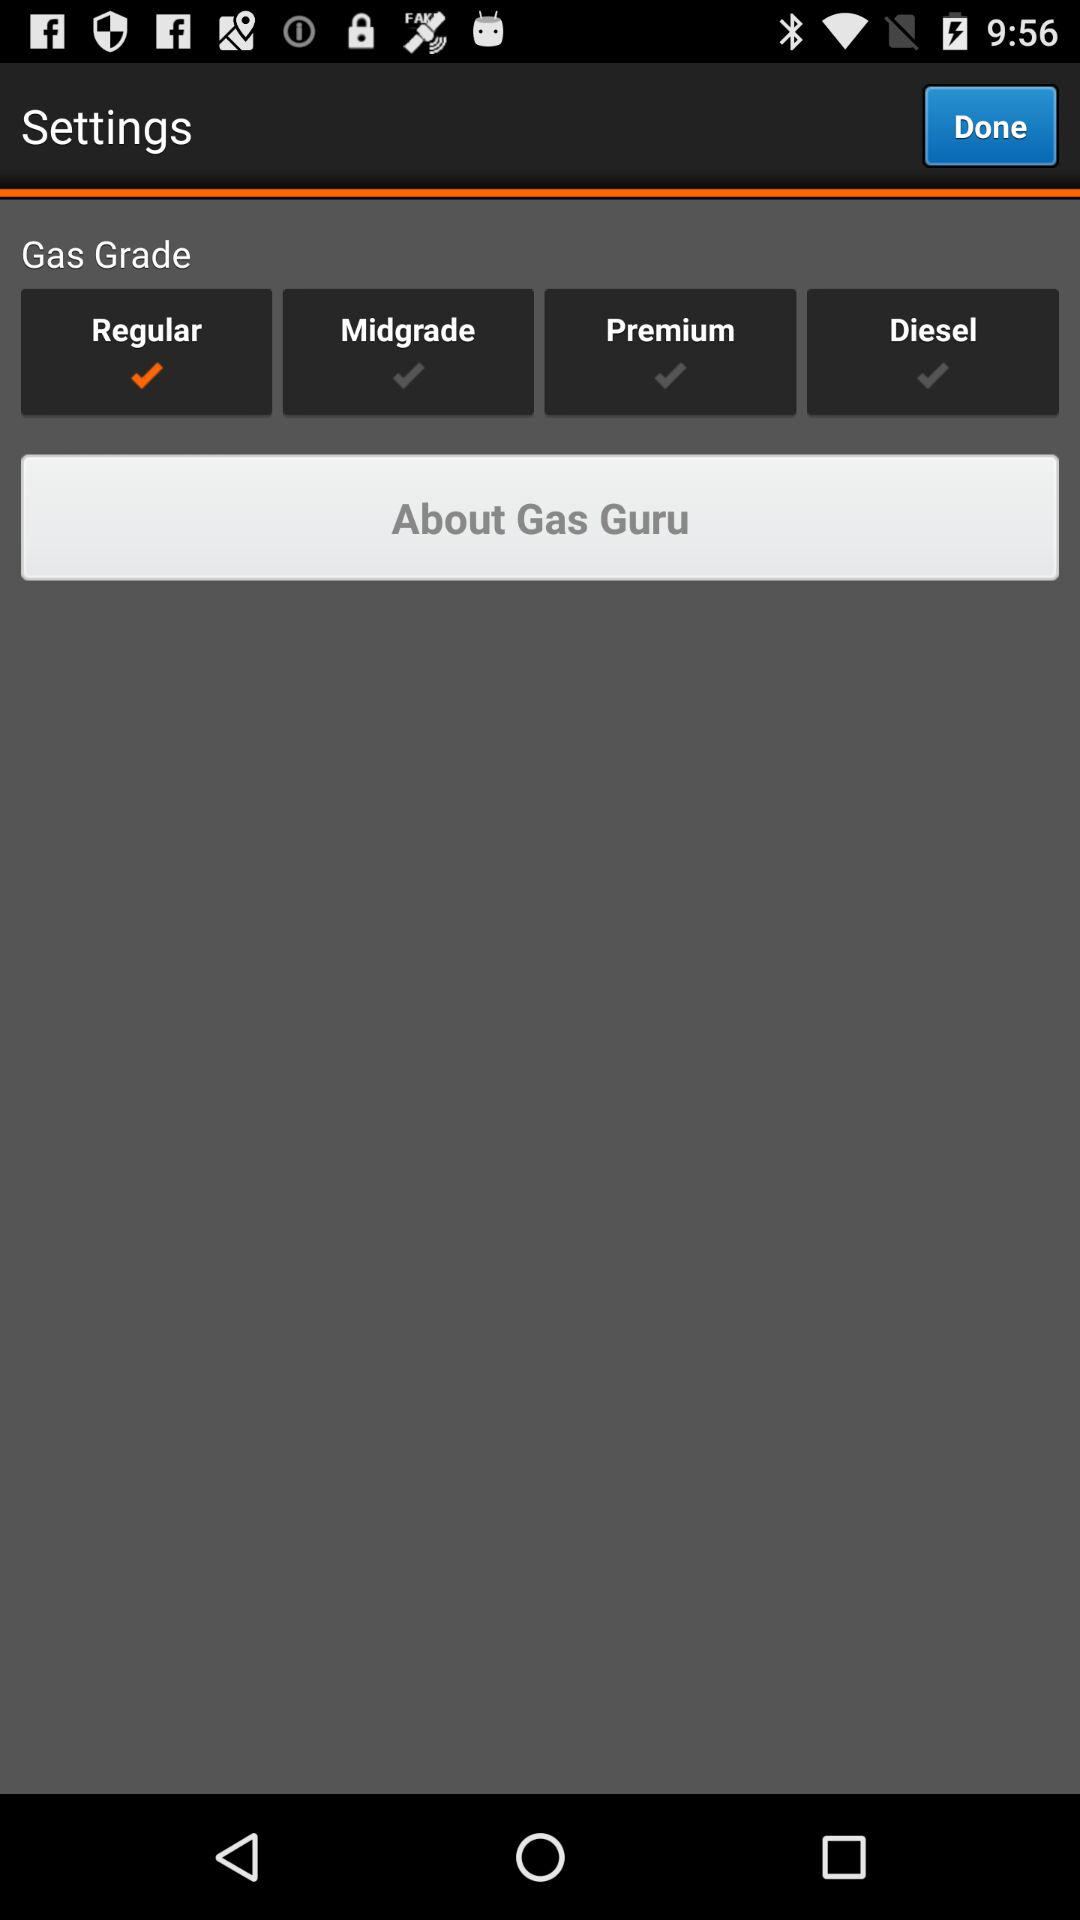How many gas grades are available?
Answer the question using a single word or phrase. 4 